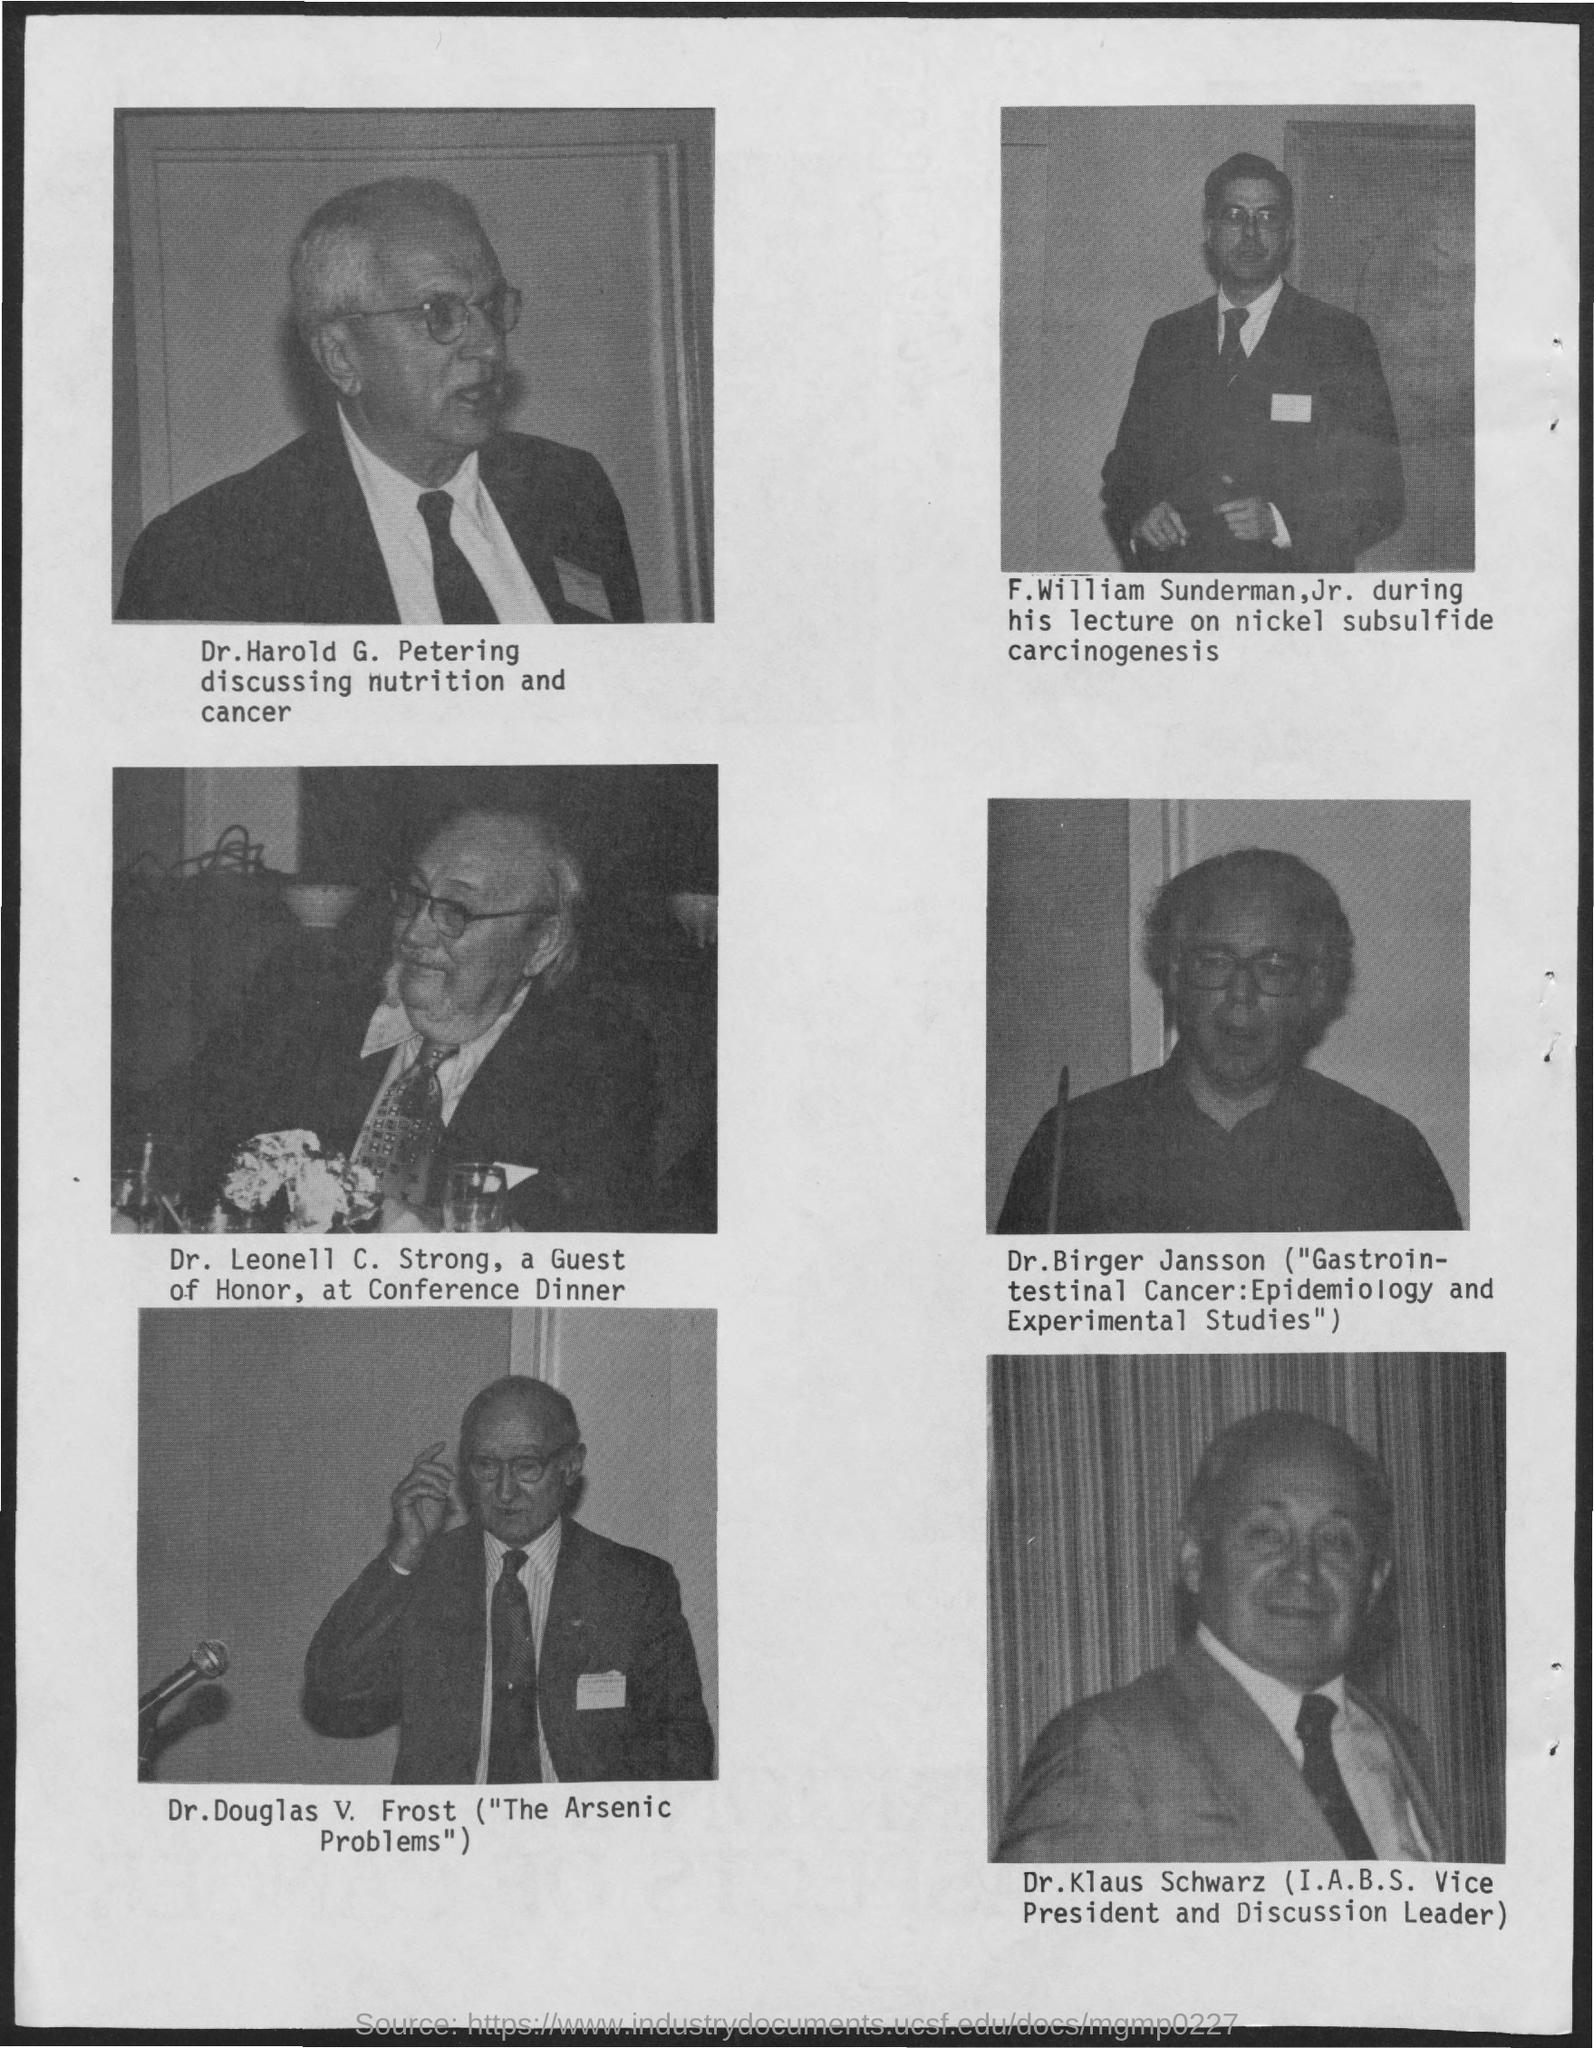Who's picture is shown in first ?
Offer a very short reply. Dr. Harold G. Petering. Who was the guest of Honor,at Conference Dinner?
Offer a very short reply. Dr. Leonell C. Strong. Who is the Vice President of I.A.B.S ?
Give a very brief answer. Dr. Klaus Schwarz. What was the position of " Dr.Klaus Schwarz" in I.A.B.S. ?
Offer a terse response. Vice President. What was " Dr.Harold G. Petering" discussing about?
Keep it short and to the point. Nutrition and Cancer. What was the topic on which "Dr.Birger Jansson " talks?
Provide a short and direct response. "Gastrointestinal Cancer:Epidemiology and Experimental Studies". 